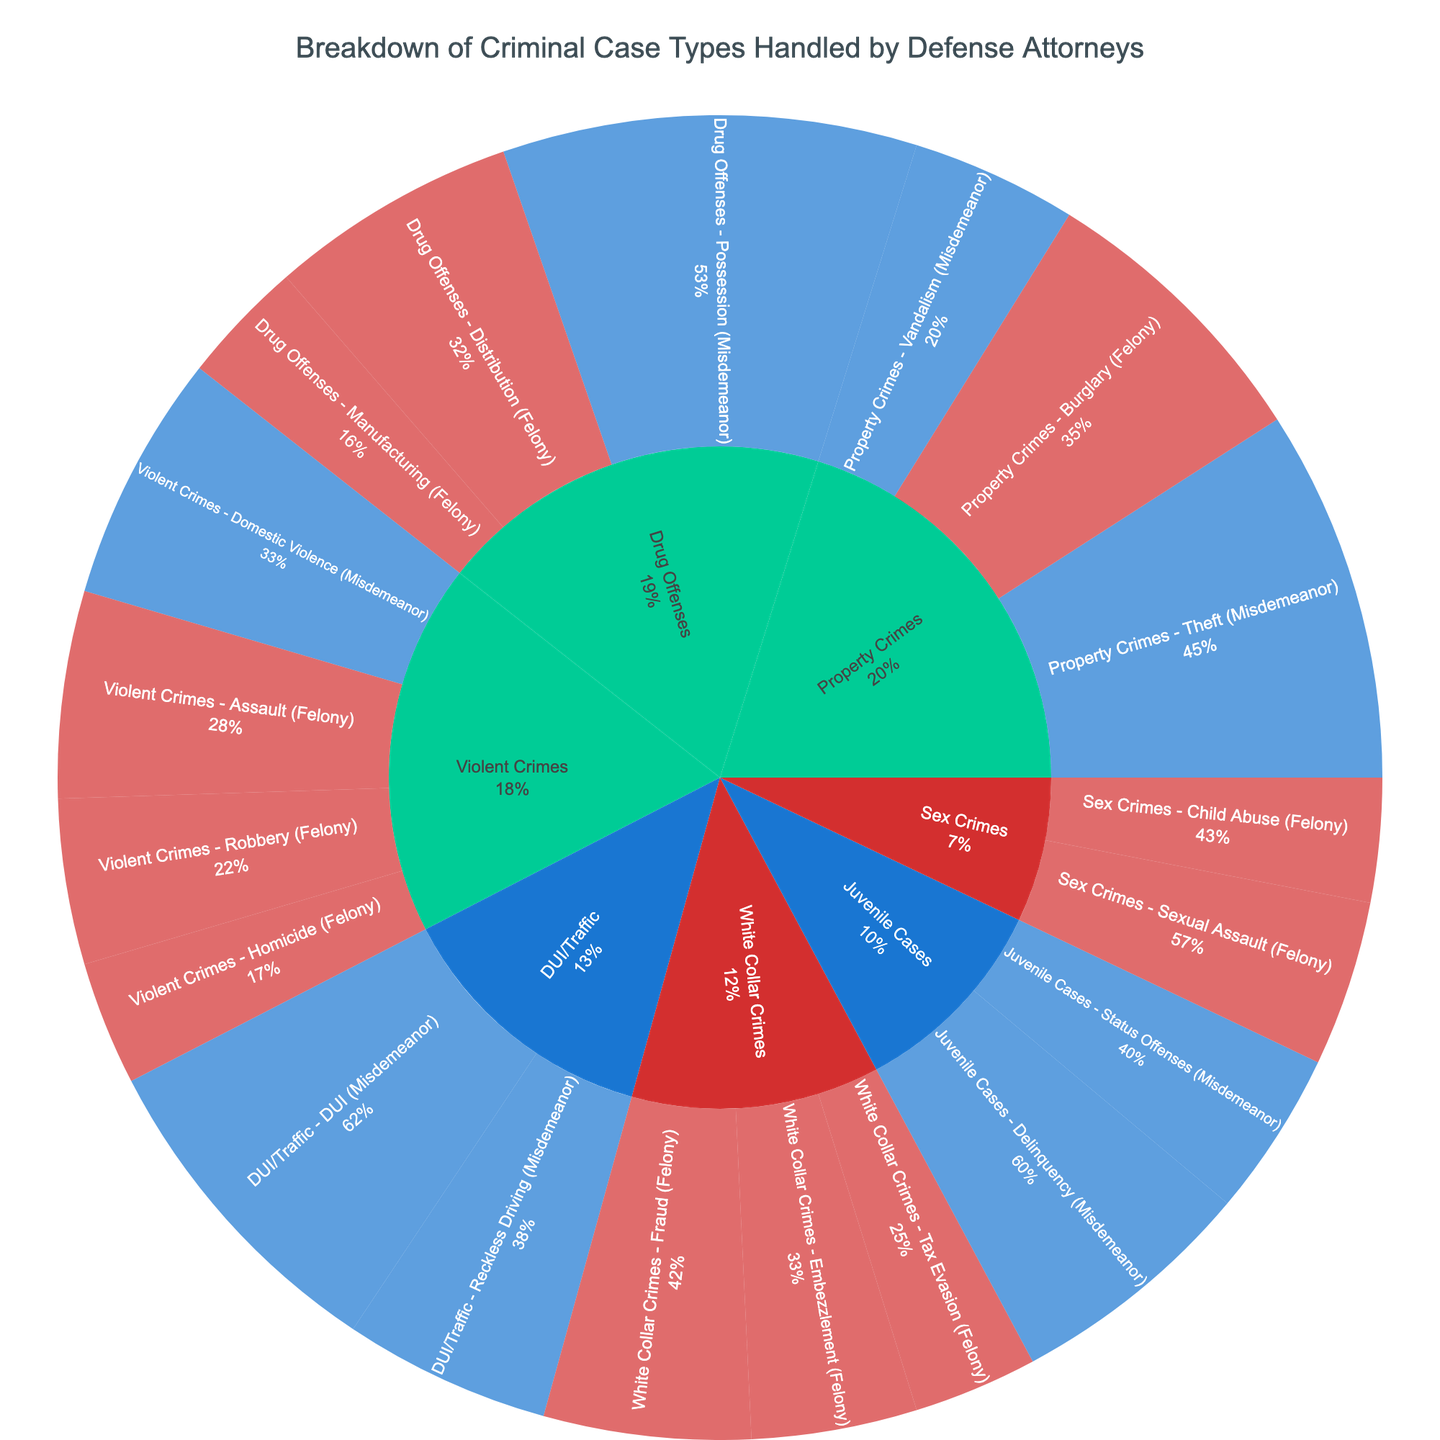What is the title of the Sunburst Plot? The title is positioned at the top of the figure in a large font. This title provides a condensed summary of the data expressed in the visualization.
Answer: Breakdown of Criminal Case Types Handled by Defense Attorneys Which category contains the highest number of cases? To determine this, look at the size and percentage representation of each main category in the Sunburst Plot. The largest segment represents the highest number of cases.
Answer: Drug Offenses What is the total number of felony cases under Violent Crimes? Add the values of all subcategories under Violent Crimes marked as Felony. These are Homicide, Assault, and Robbery. The values respectively are 15, 25, and 20. The total is 15 + 25 + 20.
Answer: 60 Compare the number of Misdemeanor cases in Property Crimes and DUI/Traffic. Which is higher? Sum the Misdemeanor values under Property Crimes and DUI/Traffic, then compare them. Property Crimes (Theft + Vandalism = 45 + 20) and DUI/Traffic (DUI + Reckless Driving = 40 + 25). Compare 65 and 65.
Answer: They are equal What percentage of the total cases is represented by Drug Offenses - Possession (Misdemeanor)? Calculate the percentage by dividing the value for Drug Offenses - Possession (50) by the overall total of all cases, then multiply by 100 to find the percentage. First, sum all values: 500. The calculation is 50 / 500 * 100.
Answer: 10% Among White Collar Crimes, which felony subcategory has the lowest number of cases? Compare the case counts for all felony subcategories under White Collar Crimes. These are Fraud, Embezzlement, and Tax Evasion with values 25, 20, and 15 respectively. Identify the smallest value.
Answer: Tax Evasion What is the ratio of misdemeanor to felony cases in Juvenile Cases? Calculate the total number of misdemeanor and felony cases under Juvenile Cases. Only misdemeanors are present: Delinquency (30) and Status Offenses (20), no felonies. The ratio is 50 to 0.
Answer: 50:0 Which subcategory has exactly 25 cases? Look for subcategories where the value equals 25. Violent Crimes - Assault, DUI/Traffic - Reckless Driving, and White Collar Crimes - Embezzlement have 25 each. Choose one to answer.
Answer: Assault How many case types fall under the category "Sex Crimes" and what are their names? Count the subcategories under Sex Crimes and list their names. There are Sexual Assault and Child Abuse.
Answer: Two, Sexual Assault and Child Abuse In terms of severity, how many categories include both misdemeanor and felony cases? Examine each category and check if they include both misdemeanor and felony case types. Violent Crimes, Property Crimes, and Drug Offenses qualify. Count these categories.
Answer: Three 